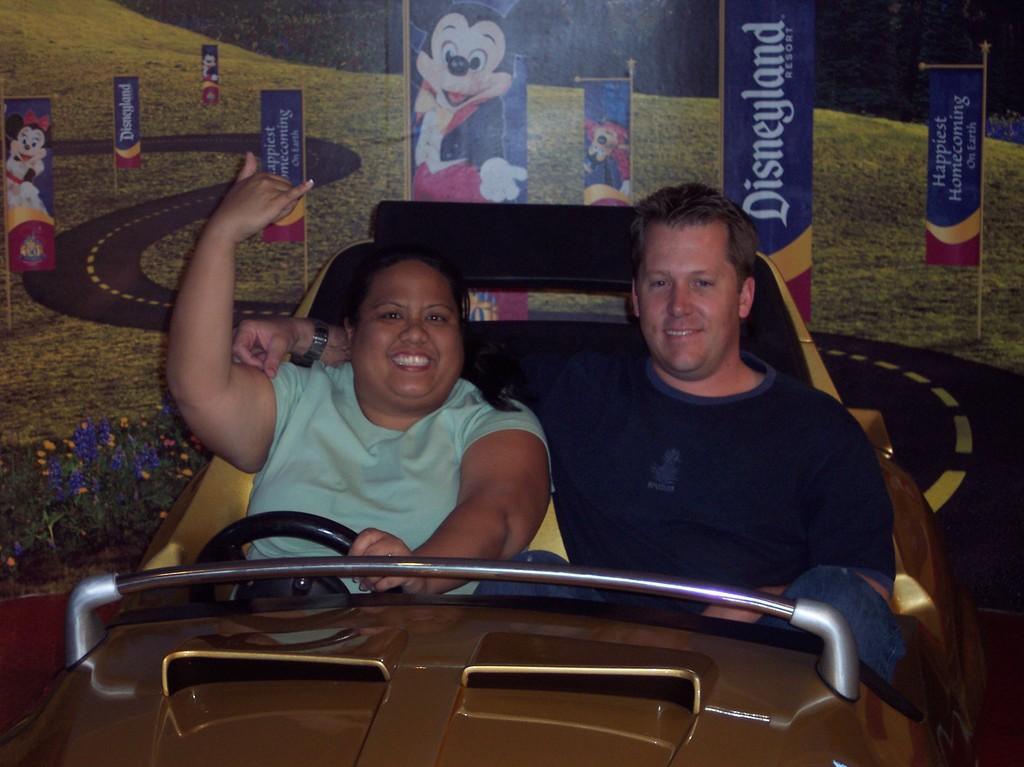How would you summarize this image in a sentence or two? In this image there are two people sitting in the car in the foreground. And It looks like there is a wallpaper in the background. 